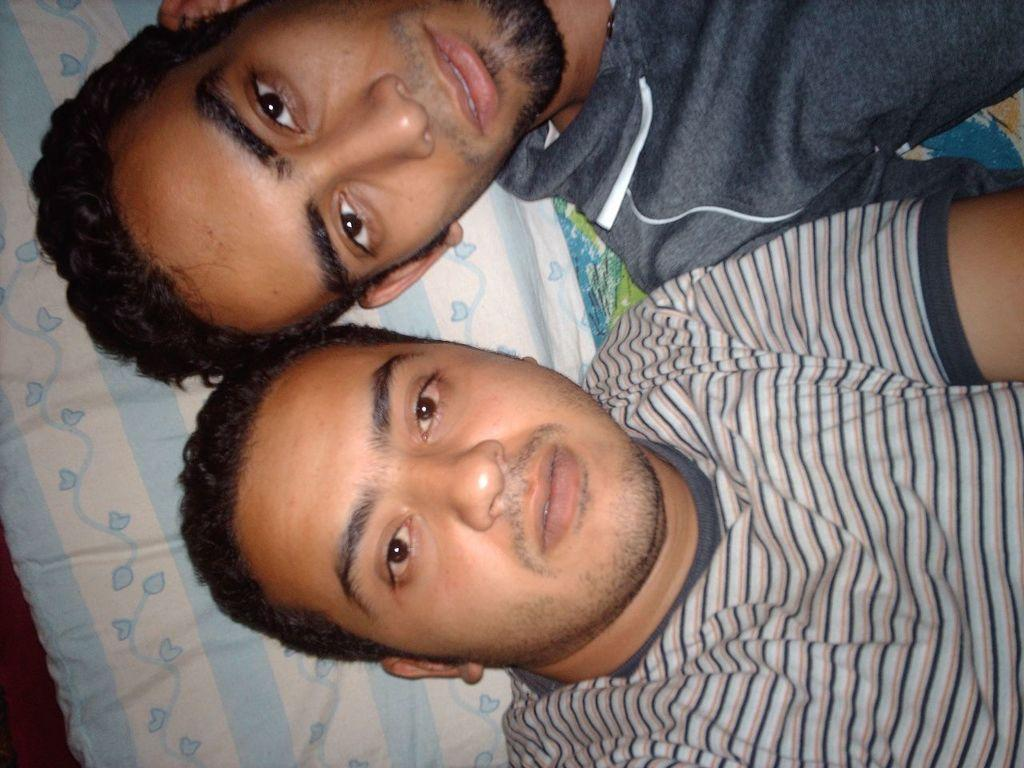Where was the image most likely taken? The image was likely taken indoors. How many people are in the foreground of the image? There are two men in the foreground of the image. What are the men wearing in the image? The men are wearing t-shirts. What are the men doing in the image? The men appear to be lying on a bed. What can be seen in the background of the image? There is a pillow visible in the background of the image. What type of glass can be seen on the floor in the image? There is no glass visible on the floor in the image. 